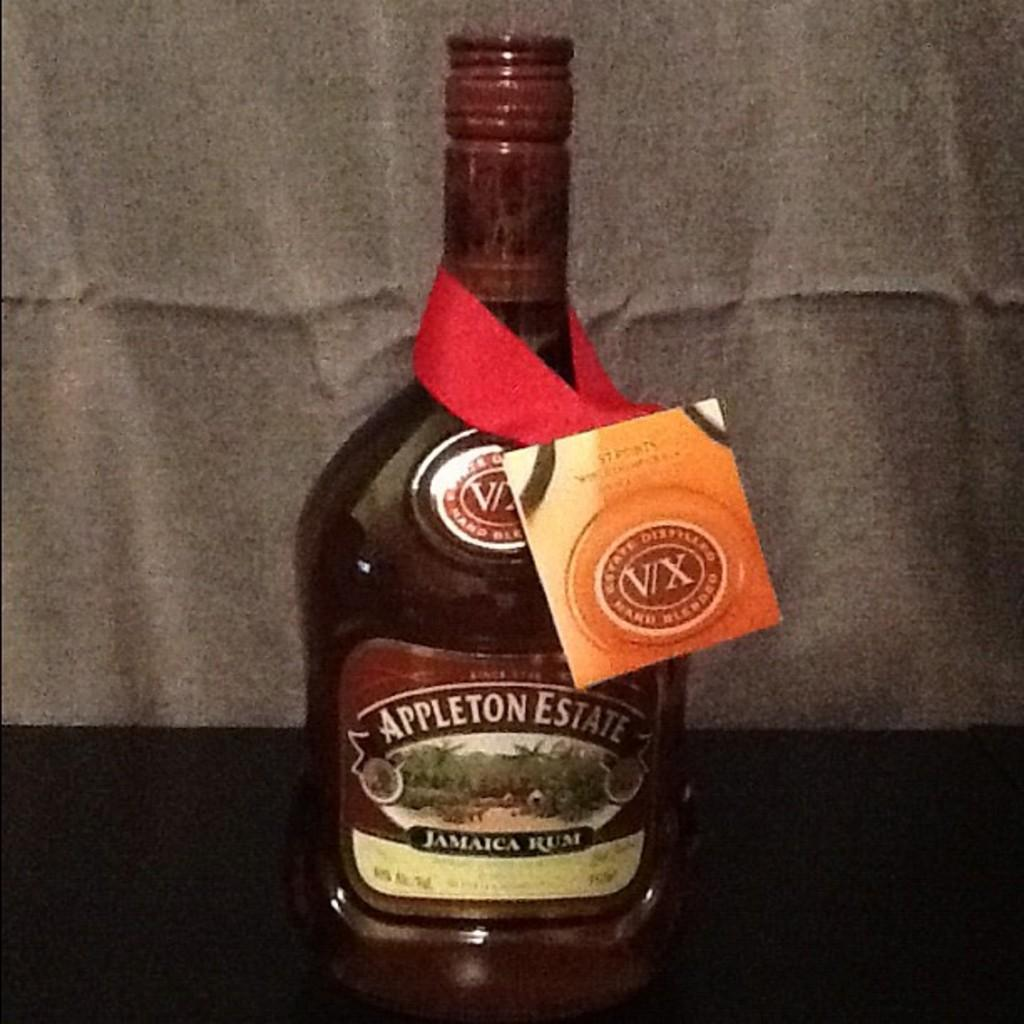<image>
Give a short and clear explanation of the subsequent image. Jamaican rum is called Appleton Estate and has a tag hanging off of it. 